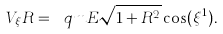Convert formula to latex. <formula><loc_0><loc_0><loc_500><loc_500>V _ { \xi } R = \ q m E \sqrt { 1 + R ^ { 2 } } \cos ( \xi ^ { 1 } ) .</formula> 